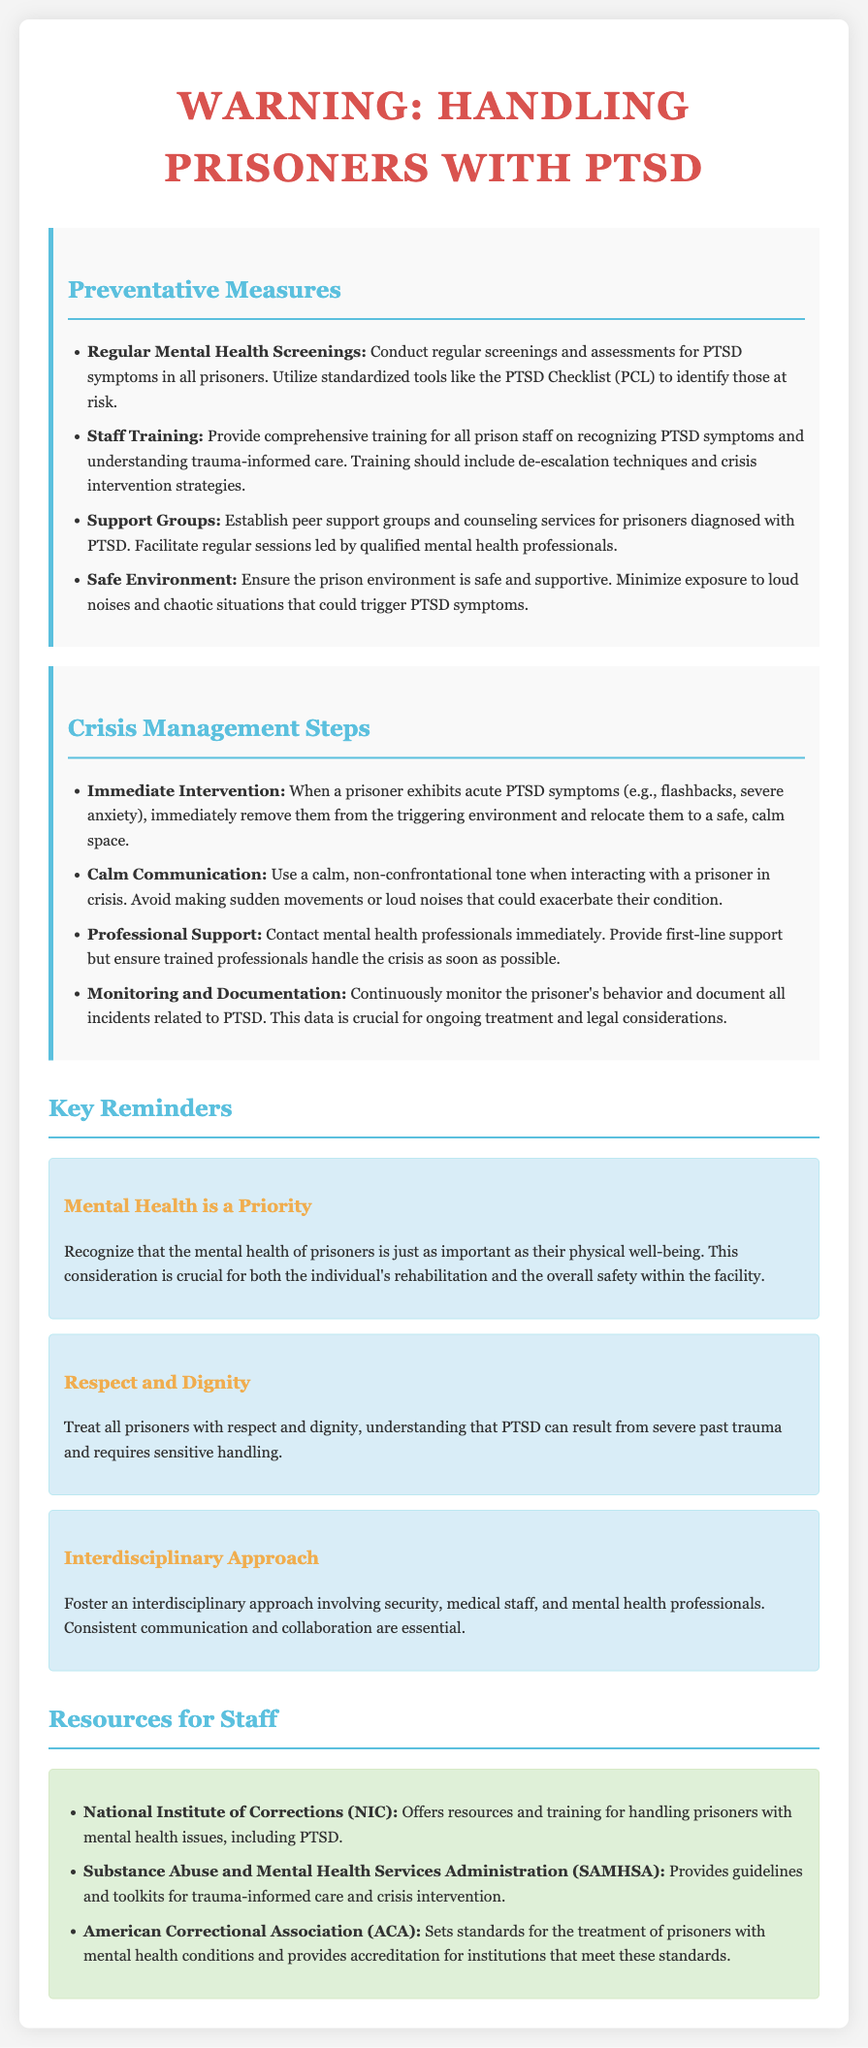what is the title of the document? The title of the document provides the main theme of the content, which is about handling prisoners with PTSD.
Answer: Warning: Handling Prisoners with PTSD how many key reminders are listed? The document enumerates the key reminders related to mental health and treatment of prisoners, which is three.
Answer: 3 which organization provides resources for handling prisoners with mental health issues? The document mentions organizations that offer training and resources, with one being specifically highlighted.
Answer: National Institute of Corrections (NIC) what is one of the preventative measures listed? The document provides several preventative measures, asking for just one of them qualifies as extracting a specific item.
Answer: Regular Mental Health Screenings what should staff use when communicating with a prisoner in crisis? The document describes specific communication approaches when dealing with prisoners showing acute PTSD symptoms, leading to a particular recommendation here.
Answer: Calm, non-confrontational tone who should be contacted for professional support during a crisis? The document indicates the need for trained professionals during a crisis management situation, culminating in this specific directive.
Answer: Mental health professionals what is emphasized as crucial for rehabilitation in the document? The document poses a significant emphasis on an aspect essential to the treatment process of prisoners, directly related to their mental health.
Answer: Mental health what type of approach is recommended in handling prisoners with PTSD? The document suggests a specific collaborative effort among various professionals to ensure proper treatment, reflecting this particular methodology.
Answer: Interdisciplinary approach 